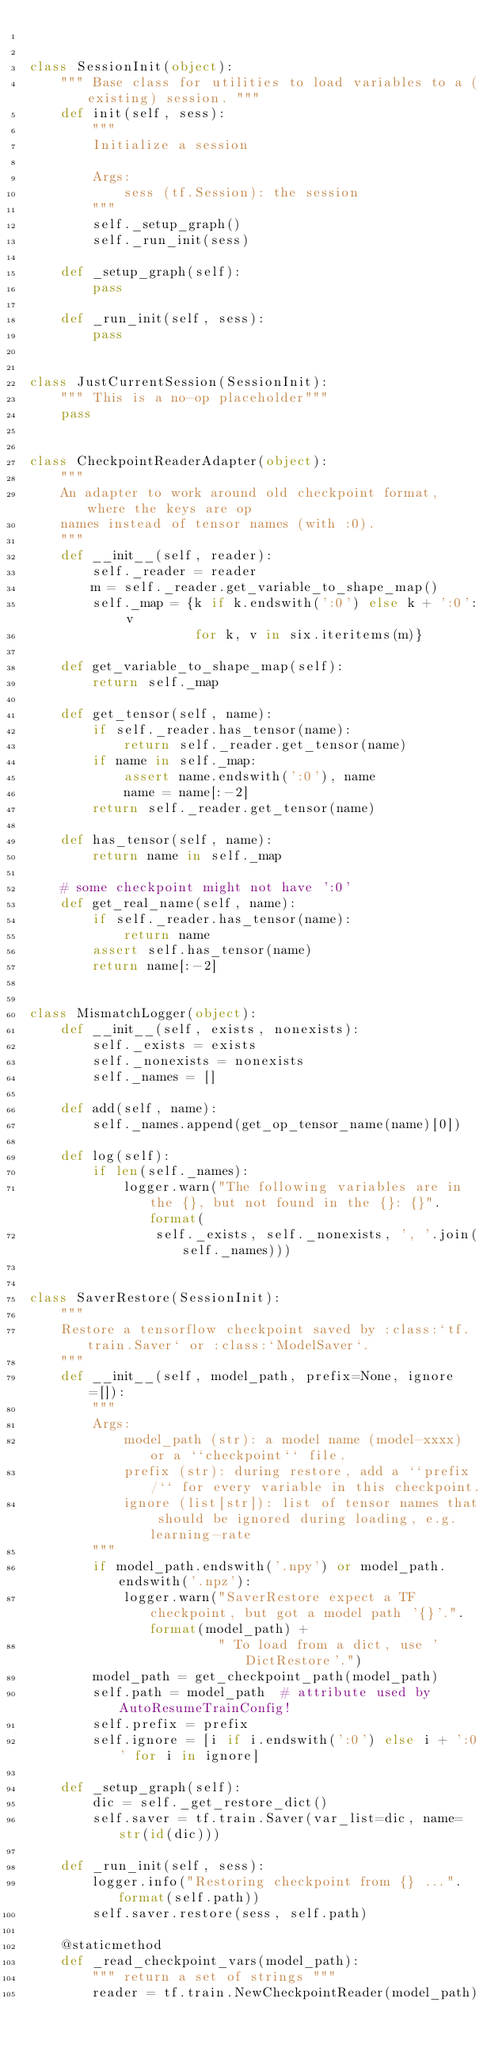Convert code to text. <code><loc_0><loc_0><loc_500><loc_500><_Python_>

class SessionInit(object):
    """ Base class for utilities to load variables to a (existing) session. """
    def init(self, sess):
        """
        Initialize a session

        Args:
            sess (tf.Session): the session
        """
        self._setup_graph()
        self._run_init(sess)

    def _setup_graph(self):
        pass

    def _run_init(self, sess):
        pass


class JustCurrentSession(SessionInit):
    """ This is a no-op placeholder"""
    pass


class CheckpointReaderAdapter(object):
    """
    An adapter to work around old checkpoint format, where the keys are op
    names instead of tensor names (with :0).
    """
    def __init__(self, reader):
        self._reader = reader
        m = self._reader.get_variable_to_shape_map()
        self._map = {k if k.endswith(':0') else k + ':0': v
                     for k, v in six.iteritems(m)}

    def get_variable_to_shape_map(self):
        return self._map

    def get_tensor(self, name):
        if self._reader.has_tensor(name):
            return self._reader.get_tensor(name)
        if name in self._map:
            assert name.endswith(':0'), name
            name = name[:-2]
        return self._reader.get_tensor(name)

    def has_tensor(self, name):
        return name in self._map

    # some checkpoint might not have ':0'
    def get_real_name(self, name):
        if self._reader.has_tensor(name):
            return name
        assert self.has_tensor(name)
        return name[:-2]


class MismatchLogger(object):
    def __init__(self, exists, nonexists):
        self._exists = exists
        self._nonexists = nonexists
        self._names = []

    def add(self, name):
        self._names.append(get_op_tensor_name(name)[0])

    def log(self):
        if len(self._names):
            logger.warn("The following variables are in the {}, but not found in the {}: {}".format(
                self._exists, self._nonexists, ', '.join(self._names)))


class SaverRestore(SessionInit):
    """
    Restore a tensorflow checkpoint saved by :class:`tf.train.Saver` or :class:`ModelSaver`.
    """
    def __init__(self, model_path, prefix=None, ignore=[]):
        """
        Args:
            model_path (str): a model name (model-xxxx) or a ``checkpoint`` file.
            prefix (str): during restore, add a ``prefix/`` for every variable in this checkpoint.
            ignore (list[str]): list of tensor names that should be ignored during loading, e.g. learning-rate
        """
        if model_path.endswith('.npy') or model_path.endswith('.npz'):
            logger.warn("SaverRestore expect a TF checkpoint, but got a model path '{}'.".format(model_path) +
                        " To load from a dict, use 'DictRestore'.")
        model_path = get_checkpoint_path(model_path)
        self.path = model_path  # attribute used by AutoResumeTrainConfig!
        self.prefix = prefix
        self.ignore = [i if i.endswith(':0') else i + ':0' for i in ignore]

    def _setup_graph(self):
        dic = self._get_restore_dict()
        self.saver = tf.train.Saver(var_list=dic, name=str(id(dic)))

    def _run_init(self, sess):
        logger.info("Restoring checkpoint from {} ...".format(self.path))
        self.saver.restore(sess, self.path)

    @staticmethod
    def _read_checkpoint_vars(model_path):
        """ return a set of strings """
        reader = tf.train.NewCheckpointReader(model_path)</code> 